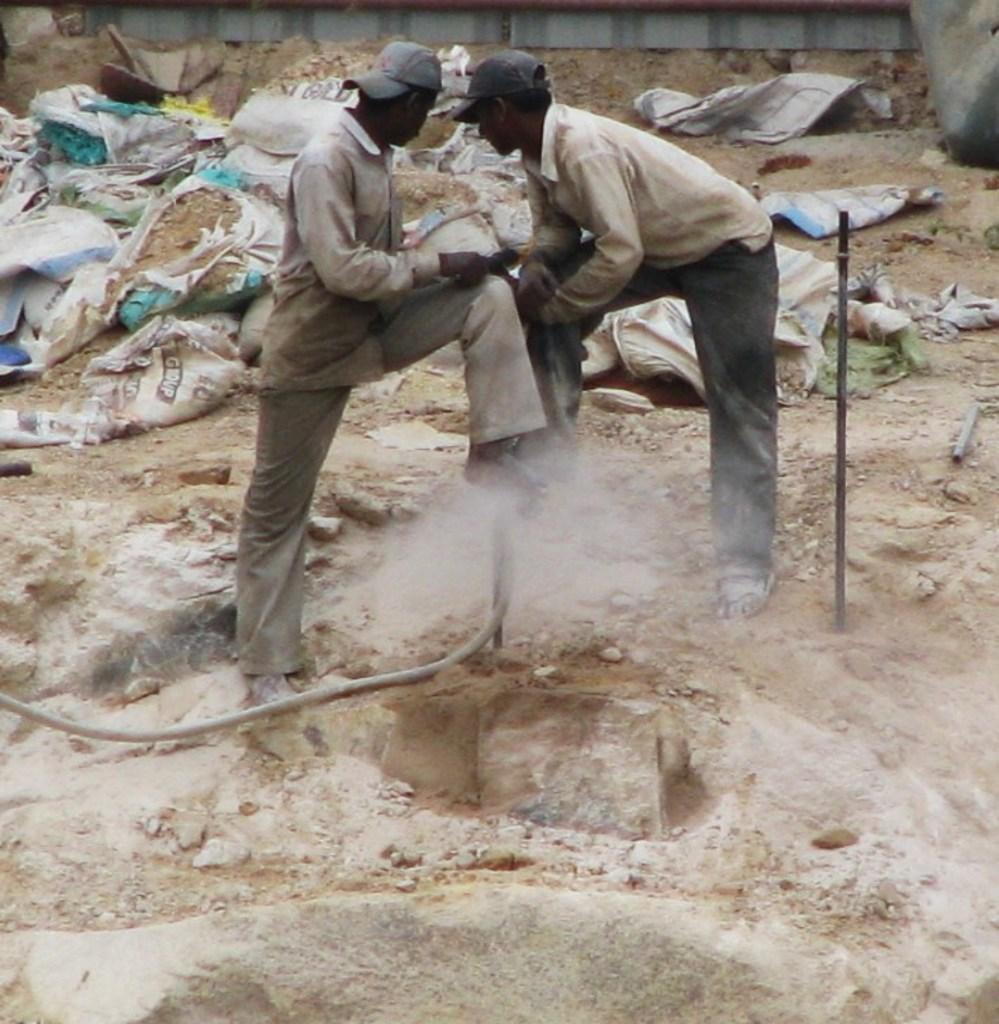Could you give a brief overview of what you see in this image? In this picture we can see two persons are standing, at the bottom there is a rock, we can see a pipe in the middle, on the right side there is a metal rod, we can see some bags and soil in the background. 